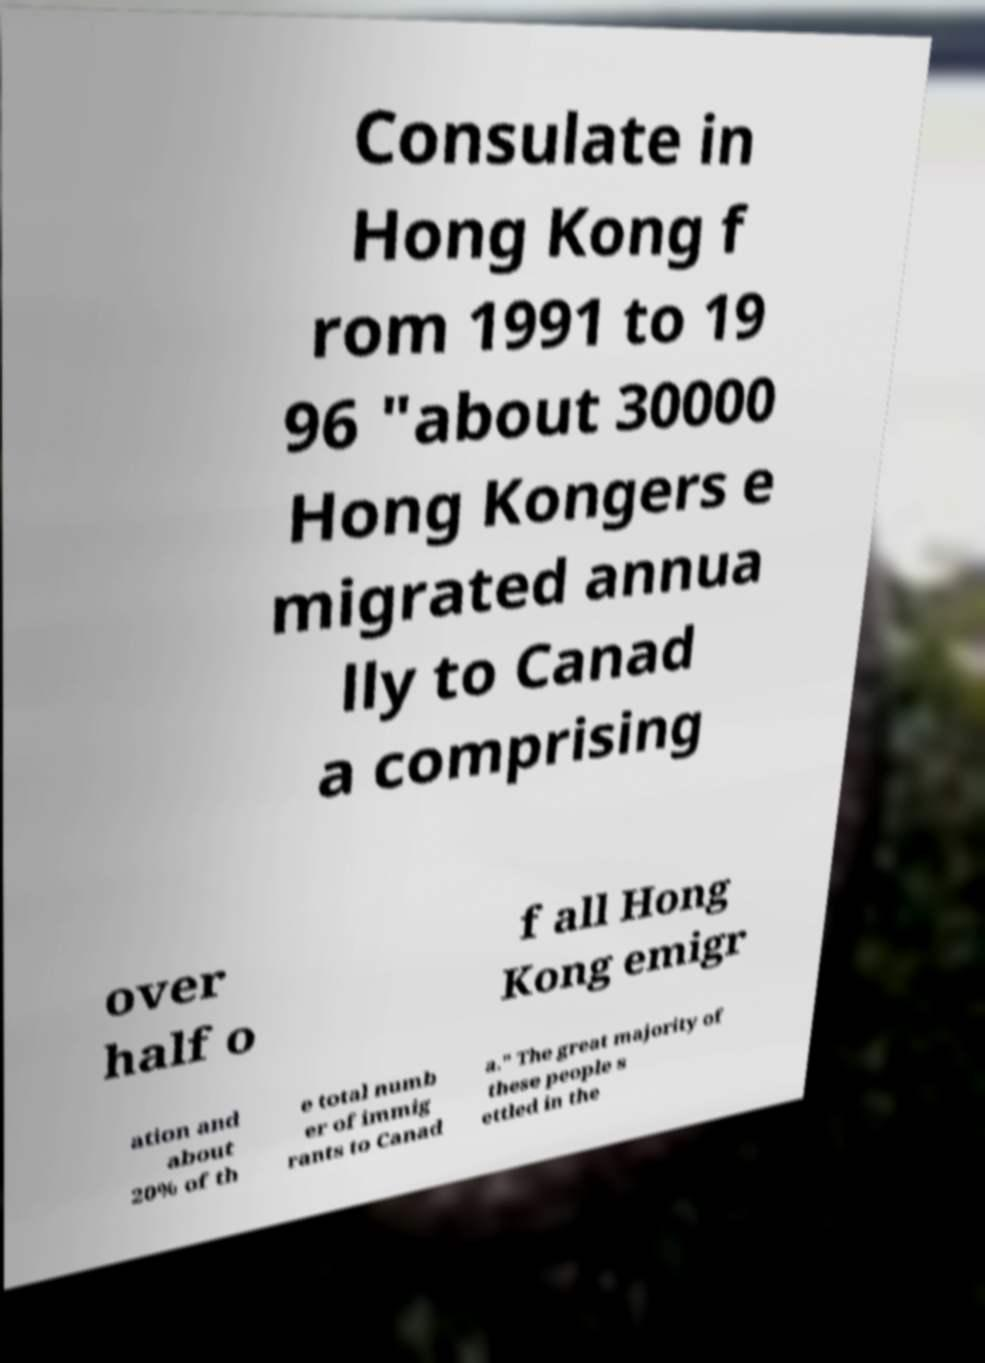What messages or text are displayed in this image? I need them in a readable, typed format. Consulate in Hong Kong f rom 1991 to 19 96 "about 30000 Hong Kongers e migrated annua lly to Canad a comprising over half o f all Hong Kong emigr ation and about 20% of th e total numb er of immig rants to Canad a." The great majority of these people s ettled in the 